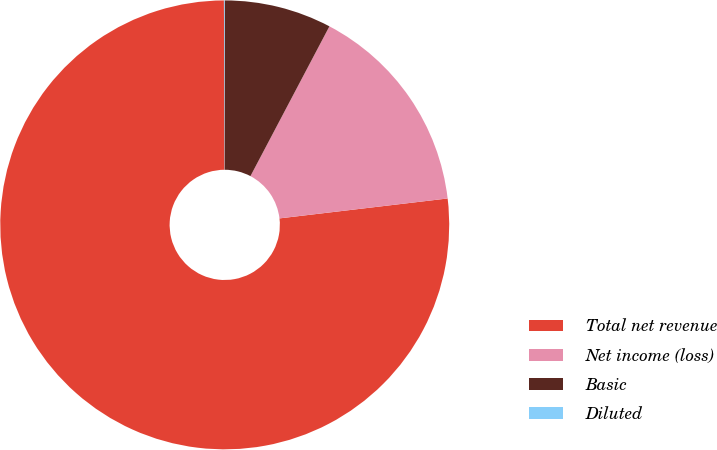Convert chart. <chart><loc_0><loc_0><loc_500><loc_500><pie_chart><fcel>Total net revenue<fcel>Net income (loss)<fcel>Basic<fcel>Diluted<nl><fcel>76.82%<fcel>15.4%<fcel>7.73%<fcel>0.05%<nl></chart> 